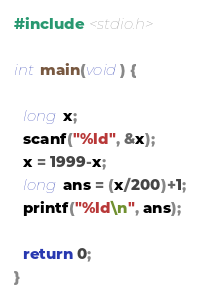Convert code to text. <code><loc_0><loc_0><loc_500><loc_500><_C_>#include <stdio.h>

int main(void) {

  long x;
  scanf("%ld", &x);
  x = 1999-x;
  long ans = (x/200)+1;
  printf("%ld\n", ans);

  return 0;
}</code> 